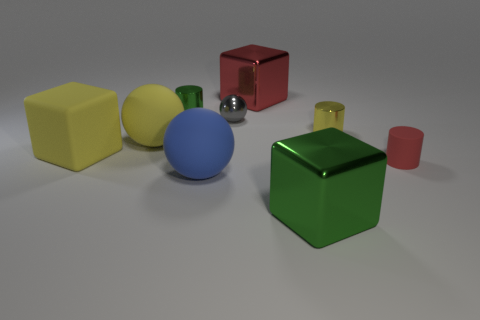What materials do the objects seem to be made of? The objects appear to be made of different materials. The yellow and green objects have matte surfaces, suggesting a plastic material, while the red cube and the blue sphere seem to have glossier surfaces, which could indicate a metallic or ceramic material. 